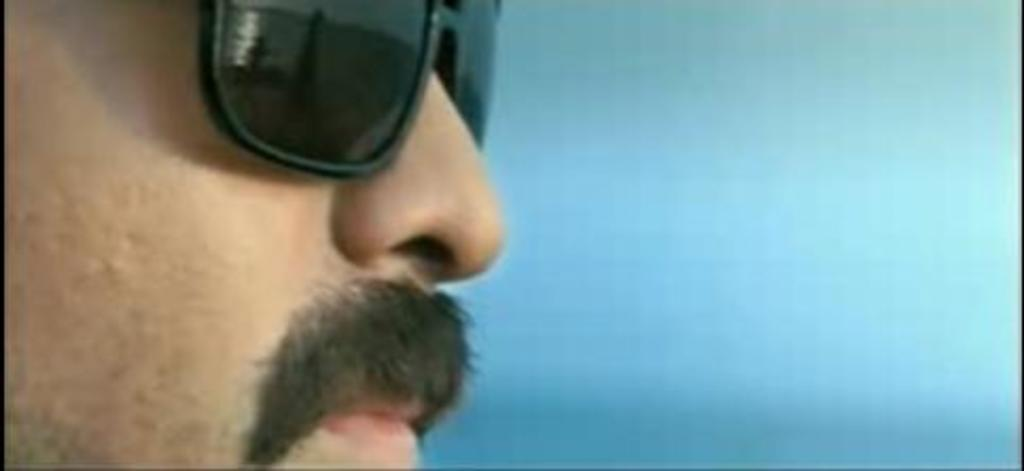What is the main subject of the image? The main subject of the image is a man's face. What facial feature does the man have? The man has a mustache. What accessory is the man wearing in the image? The man is wearing spectacles. What type of fire can be seen in the image? There is no fire present in the image; it features a man's face with a mustache and spectacles. What role does the man play in the army in the image? There is no indication of the man being in the army or having any military role in the image. 